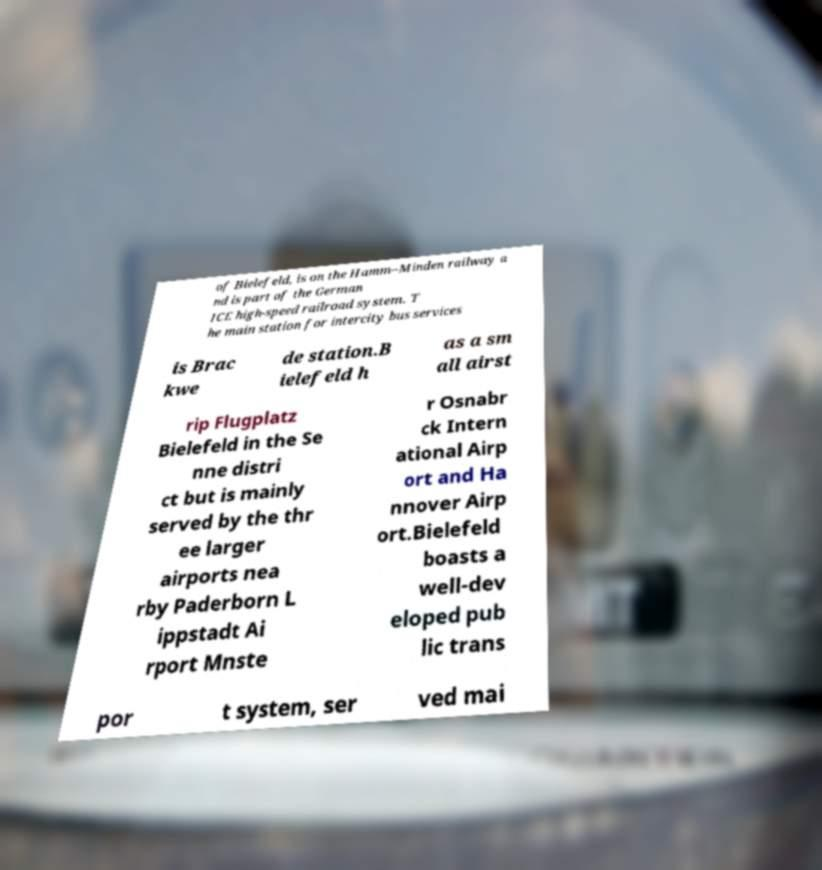I need the written content from this picture converted into text. Can you do that? of Bielefeld, is on the Hamm–Minden railway a nd is part of the German ICE high-speed railroad system. T he main station for intercity bus services is Brac kwe de station.B ielefeld h as a sm all airst rip Flugplatz Bielefeld in the Se nne distri ct but is mainly served by the thr ee larger airports nea rby Paderborn L ippstadt Ai rport Mnste r Osnabr ck Intern ational Airp ort and Ha nnover Airp ort.Bielefeld boasts a well-dev eloped pub lic trans por t system, ser ved mai 